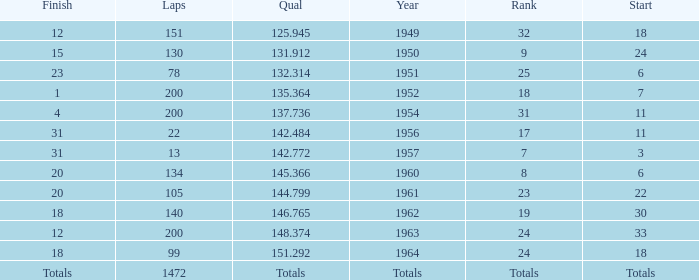Name the rank with laps of 200 and qual of 148.374 24.0. 